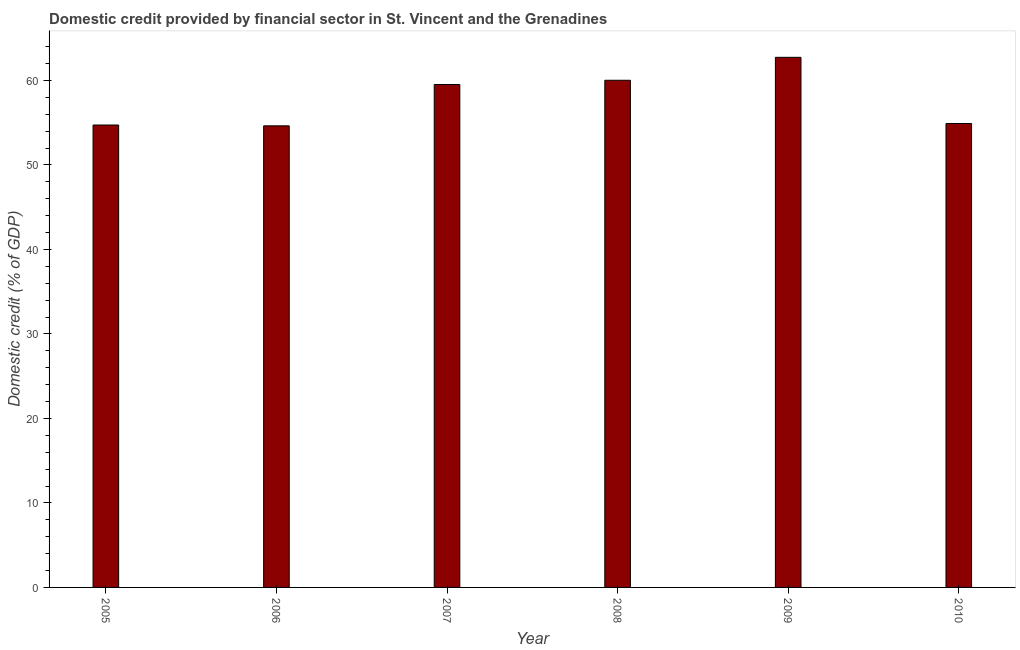Does the graph contain any zero values?
Your answer should be very brief. No. What is the title of the graph?
Your response must be concise. Domestic credit provided by financial sector in St. Vincent and the Grenadines. What is the label or title of the Y-axis?
Keep it short and to the point. Domestic credit (% of GDP). What is the domestic credit provided by financial sector in 2008?
Keep it short and to the point. 60.03. Across all years, what is the maximum domestic credit provided by financial sector?
Give a very brief answer. 62.74. Across all years, what is the minimum domestic credit provided by financial sector?
Keep it short and to the point. 54.63. In which year was the domestic credit provided by financial sector maximum?
Your response must be concise. 2009. What is the sum of the domestic credit provided by financial sector?
Ensure brevity in your answer.  346.57. What is the difference between the domestic credit provided by financial sector in 2006 and 2007?
Ensure brevity in your answer.  -4.89. What is the average domestic credit provided by financial sector per year?
Make the answer very short. 57.76. What is the median domestic credit provided by financial sector?
Make the answer very short. 57.22. In how many years, is the domestic credit provided by financial sector greater than 16 %?
Your response must be concise. 6. What is the ratio of the domestic credit provided by financial sector in 2008 to that in 2010?
Provide a short and direct response. 1.09. Is the domestic credit provided by financial sector in 2006 less than that in 2010?
Keep it short and to the point. Yes. Is the difference between the domestic credit provided by financial sector in 2007 and 2010 greater than the difference between any two years?
Offer a terse response. No. What is the difference between the highest and the second highest domestic credit provided by financial sector?
Your response must be concise. 2.71. What is the difference between the highest and the lowest domestic credit provided by financial sector?
Keep it short and to the point. 8.11. In how many years, is the domestic credit provided by financial sector greater than the average domestic credit provided by financial sector taken over all years?
Provide a succinct answer. 3. How many bars are there?
Your answer should be very brief. 6. Are the values on the major ticks of Y-axis written in scientific E-notation?
Make the answer very short. No. What is the Domestic credit (% of GDP) in 2005?
Ensure brevity in your answer.  54.73. What is the Domestic credit (% of GDP) of 2006?
Provide a short and direct response. 54.63. What is the Domestic credit (% of GDP) of 2007?
Ensure brevity in your answer.  59.53. What is the Domestic credit (% of GDP) of 2008?
Your answer should be very brief. 60.03. What is the Domestic credit (% of GDP) in 2009?
Keep it short and to the point. 62.74. What is the Domestic credit (% of GDP) in 2010?
Provide a succinct answer. 54.91. What is the difference between the Domestic credit (% of GDP) in 2005 and 2006?
Offer a terse response. 0.1. What is the difference between the Domestic credit (% of GDP) in 2005 and 2007?
Your response must be concise. -4.79. What is the difference between the Domestic credit (% of GDP) in 2005 and 2008?
Make the answer very short. -5.3. What is the difference between the Domestic credit (% of GDP) in 2005 and 2009?
Your answer should be compact. -8.01. What is the difference between the Domestic credit (% of GDP) in 2005 and 2010?
Offer a very short reply. -0.18. What is the difference between the Domestic credit (% of GDP) in 2006 and 2007?
Provide a short and direct response. -4.89. What is the difference between the Domestic credit (% of GDP) in 2006 and 2008?
Offer a very short reply. -5.39. What is the difference between the Domestic credit (% of GDP) in 2006 and 2009?
Offer a terse response. -8.11. What is the difference between the Domestic credit (% of GDP) in 2006 and 2010?
Make the answer very short. -0.28. What is the difference between the Domestic credit (% of GDP) in 2007 and 2008?
Your response must be concise. -0.5. What is the difference between the Domestic credit (% of GDP) in 2007 and 2009?
Your response must be concise. -3.22. What is the difference between the Domestic credit (% of GDP) in 2007 and 2010?
Offer a very short reply. 4.62. What is the difference between the Domestic credit (% of GDP) in 2008 and 2009?
Give a very brief answer. -2.72. What is the difference between the Domestic credit (% of GDP) in 2008 and 2010?
Your response must be concise. 5.12. What is the difference between the Domestic credit (% of GDP) in 2009 and 2010?
Provide a succinct answer. 7.83. What is the ratio of the Domestic credit (% of GDP) in 2005 to that in 2007?
Make the answer very short. 0.92. What is the ratio of the Domestic credit (% of GDP) in 2005 to that in 2008?
Keep it short and to the point. 0.91. What is the ratio of the Domestic credit (% of GDP) in 2005 to that in 2009?
Make the answer very short. 0.87. What is the ratio of the Domestic credit (% of GDP) in 2005 to that in 2010?
Offer a very short reply. 1. What is the ratio of the Domestic credit (% of GDP) in 2006 to that in 2007?
Your answer should be compact. 0.92. What is the ratio of the Domestic credit (% of GDP) in 2006 to that in 2008?
Offer a terse response. 0.91. What is the ratio of the Domestic credit (% of GDP) in 2006 to that in 2009?
Your response must be concise. 0.87. What is the ratio of the Domestic credit (% of GDP) in 2007 to that in 2009?
Provide a succinct answer. 0.95. What is the ratio of the Domestic credit (% of GDP) in 2007 to that in 2010?
Provide a short and direct response. 1.08. What is the ratio of the Domestic credit (% of GDP) in 2008 to that in 2009?
Offer a very short reply. 0.96. What is the ratio of the Domestic credit (% of GDP) in 2008 to that in 2010?
Your answer should be compact. 1.09. What is the ratio of the Domestic credit (% of GDP) in 2009 to that in 2010?
Provide a succinct answer. 1.14. 